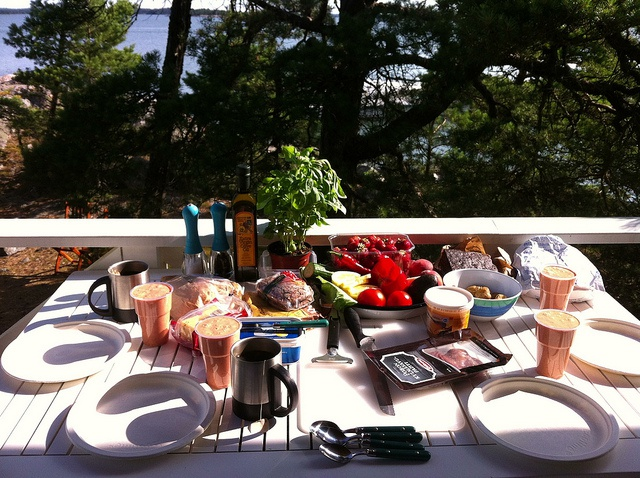Describe the objects in this image and their specific colors. I can see dining table in white, gray, and black tones, potted plant in ivory, black, and darkgreen tones, cup in white, black, and gray tones, bottle in white, black, and maroon tones, and cup in white, black, gray, and tan tones in this image. 